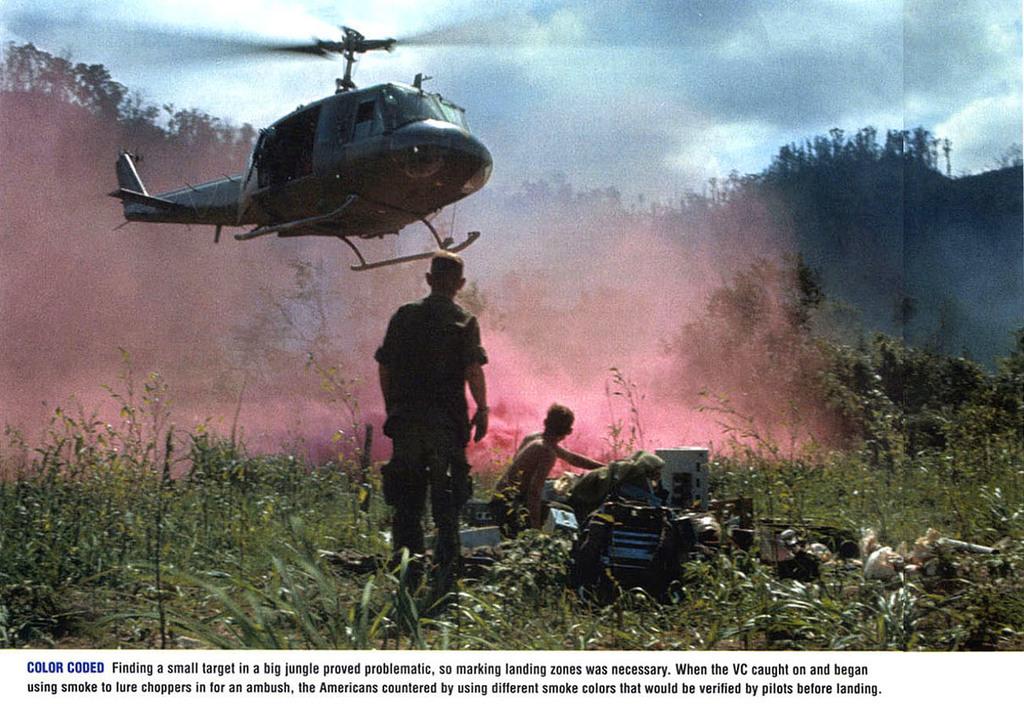What did they use to lure choppers in for an ambush?
Give a very brief answer. Smoke. What is the name of the image?
Your response must be concise. Color coded. 